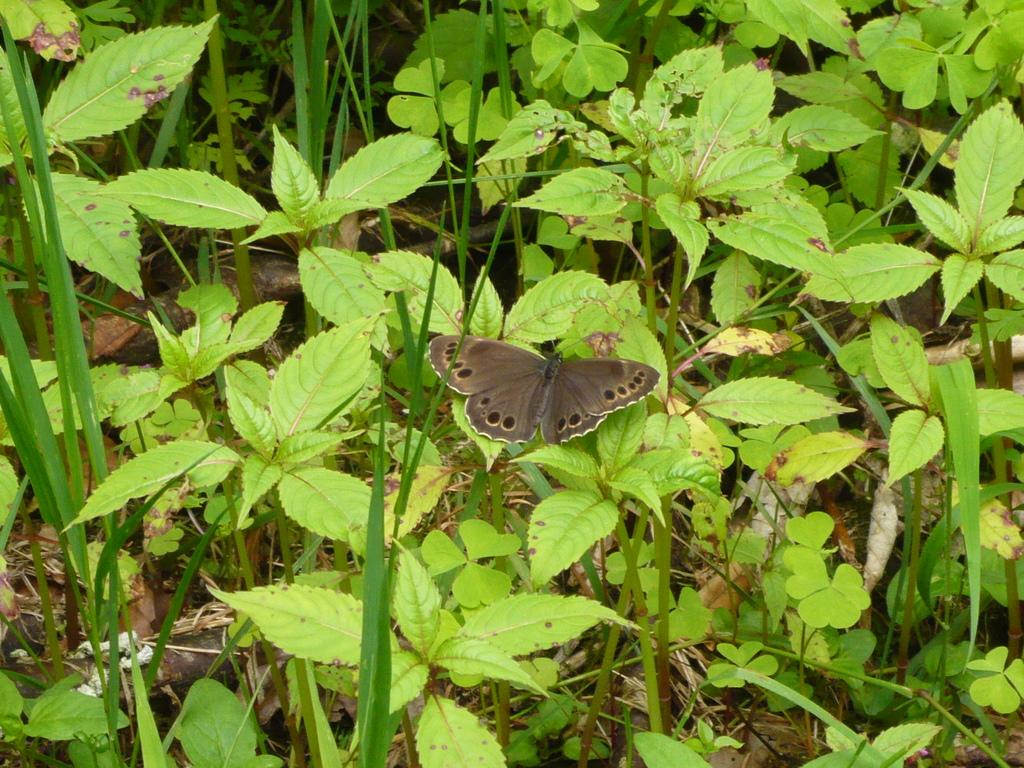What is the main subject of the image? There is a butterfly in the image. Where is the butterfly located? The butterfly is on a leaf. What else can be seen in the image besides the butterfly? There are plants visible in the image. What type of party is the butterfly attending in the image? There is no party present in the image, and the butterfly is not attending any event. 